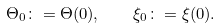<formula> <loc_0><loc_0><loc_500><loc_500>\Theta _ { 0 } \colon = \Theta ( 0 ) , \quad \xi _ { 0 } \colon = \xi ( 0 ) .</formula> 